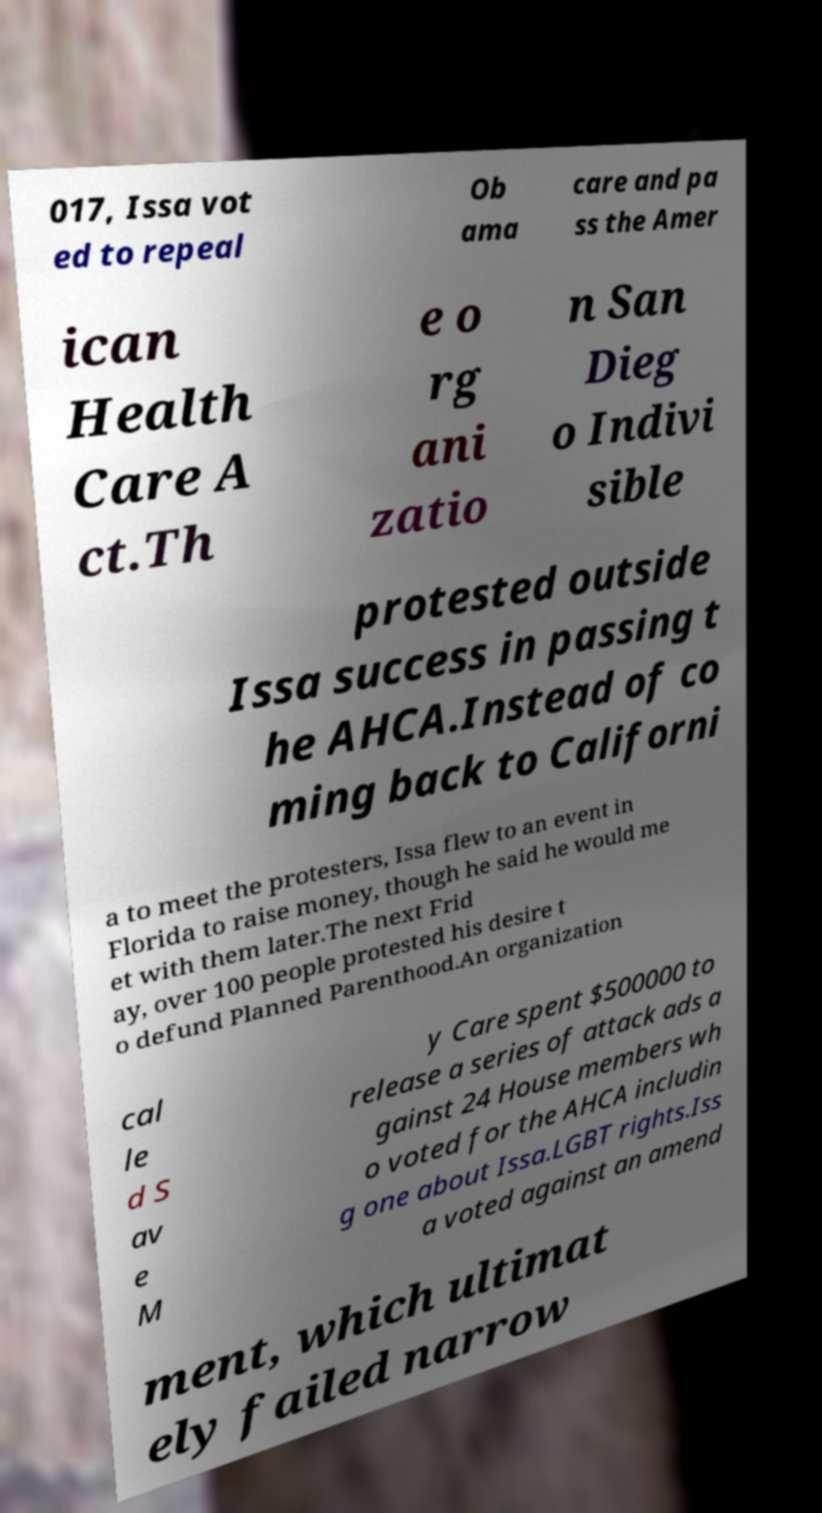Please identify and transcribe the text found in this image. 017, Issa vot ed to repeal Ob ama care and pa ss the Amer ican Health Care A ct.Th e o rg ani zatio n San Dieg o Indivi sible protested outside Issa success in passing t he AHCA.Instead of co ming back to Californi a to meet the protesters, Issa flew to an event in Florida to raise money, though he said he would me et with them later.The next Frid ay, over 100 people protested his desire t o defund Planned Parenthood.An organization cal le d S av e M y Care spent $500000 to release a series of attack ads a gainst 24 House members wh o voted for the AHCA includin g one about Issa.LGBT rights.Iss a voted against an amend ment, which ultimat ely failed narrow 